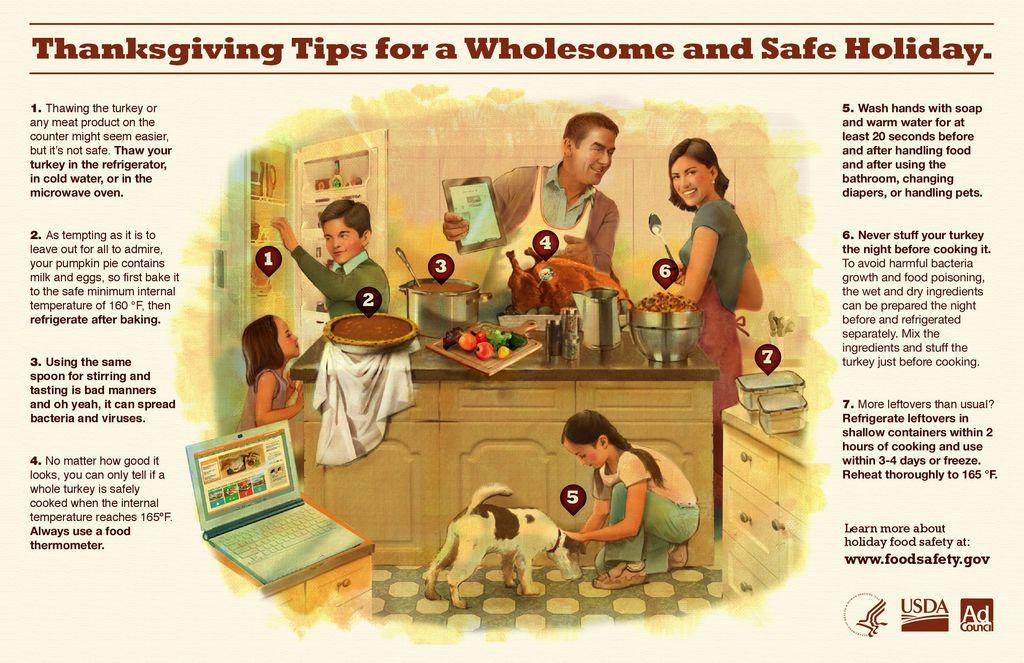What holiday are the tips for?
Provide a short and direct response. Thanksgiving. What company is shown in the middle at the bottom right?
Offer a very short reply. Usda. 